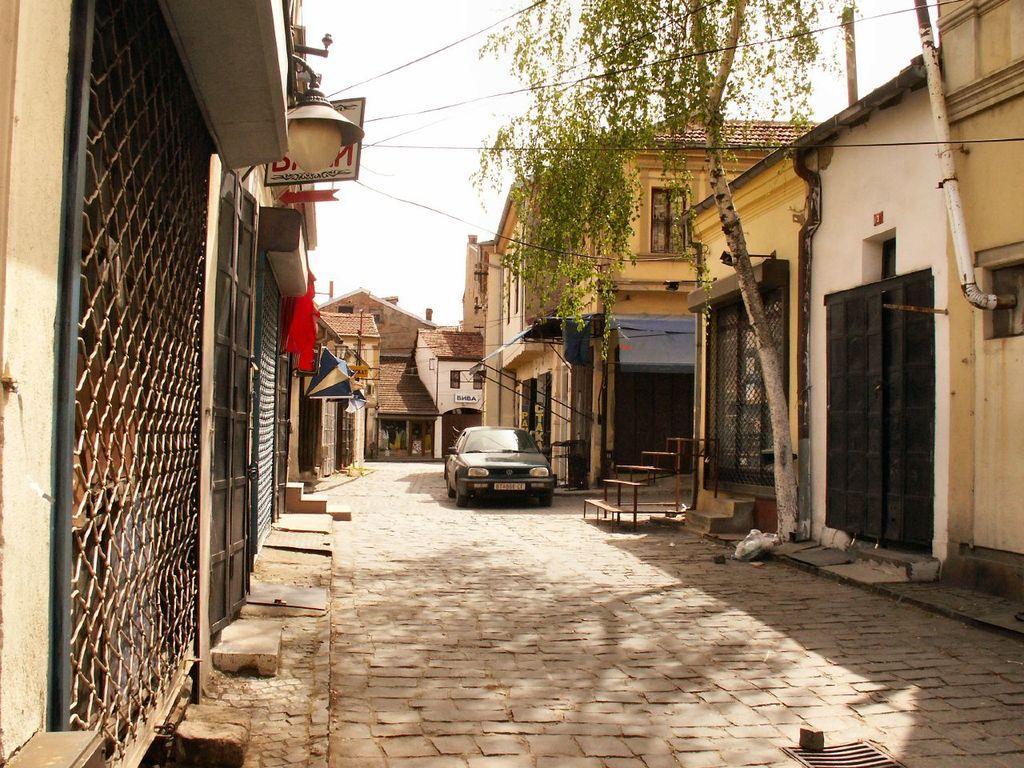In one or two sentences, can you explain what this image depicts? This image consists of a car parked on the road. To the left and right there are houses. To the right, there is a tree. At the top, there is a sky. At the bottom, there is a road. 